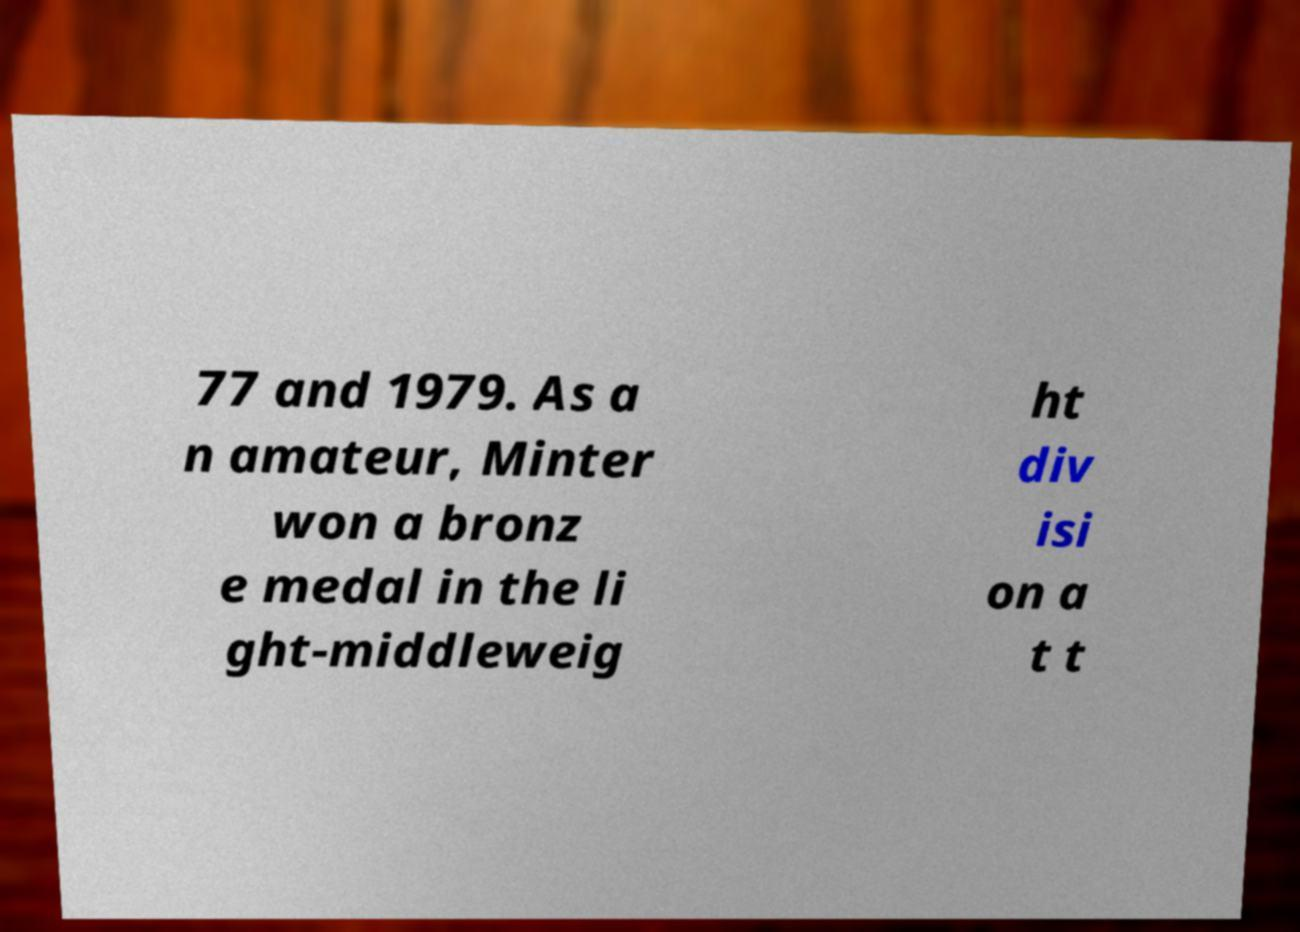I need the written content from this picture converted into text. Can you do that? 77 and 1979. As a n amateur, Minter won a bronz e medal in the li ght-middleweig ht div isi on a t t 